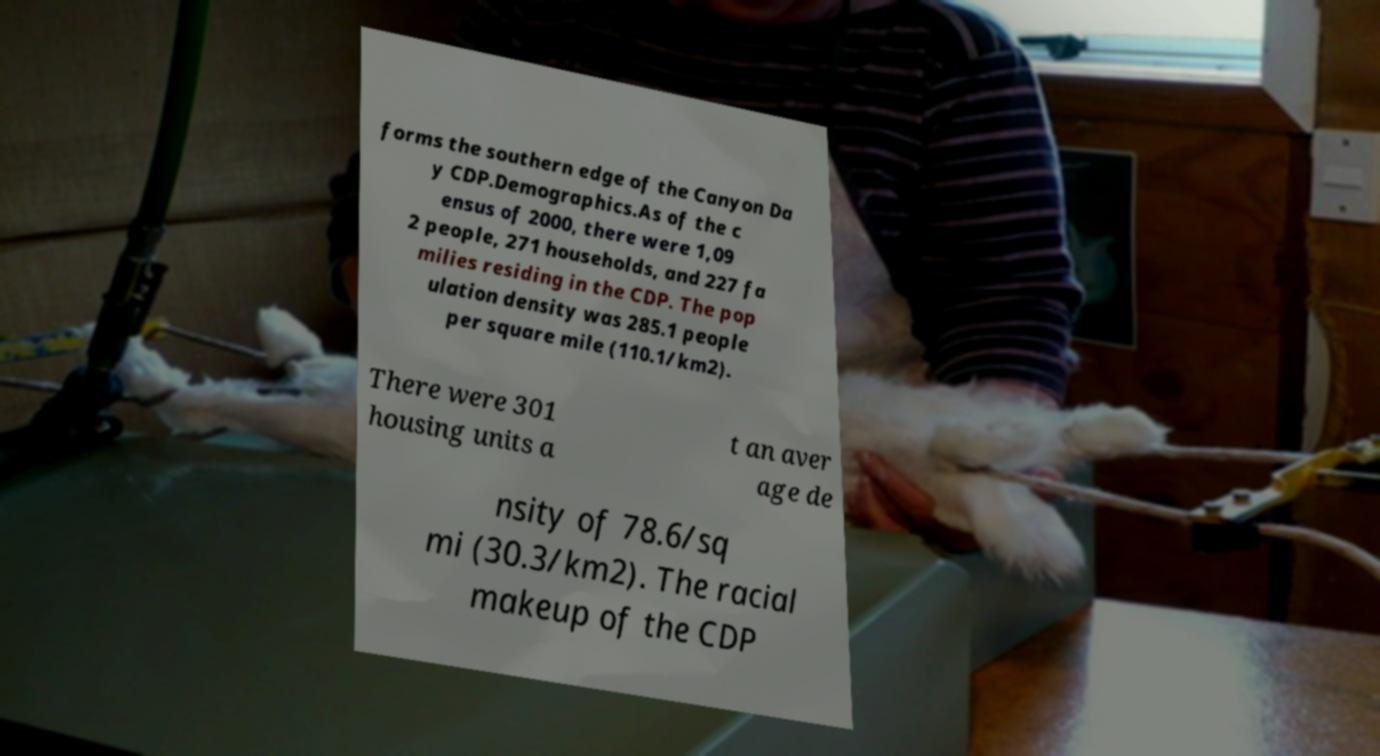Please identify and transcribe the text found in this image. forms the southern edge of the Canyon Da y CDP.Demographics.As of the c ensus of 2000, there were 1,09 2 people, 271 households, and 227 fa milies residing in the CDP. The pop ulation density was 285.1 people per square mile (110.1/km2). There were 301 housing units a t an aver age de nsity of 78.6/sq mi (30.3/km2). The racial makeup of the CDP 